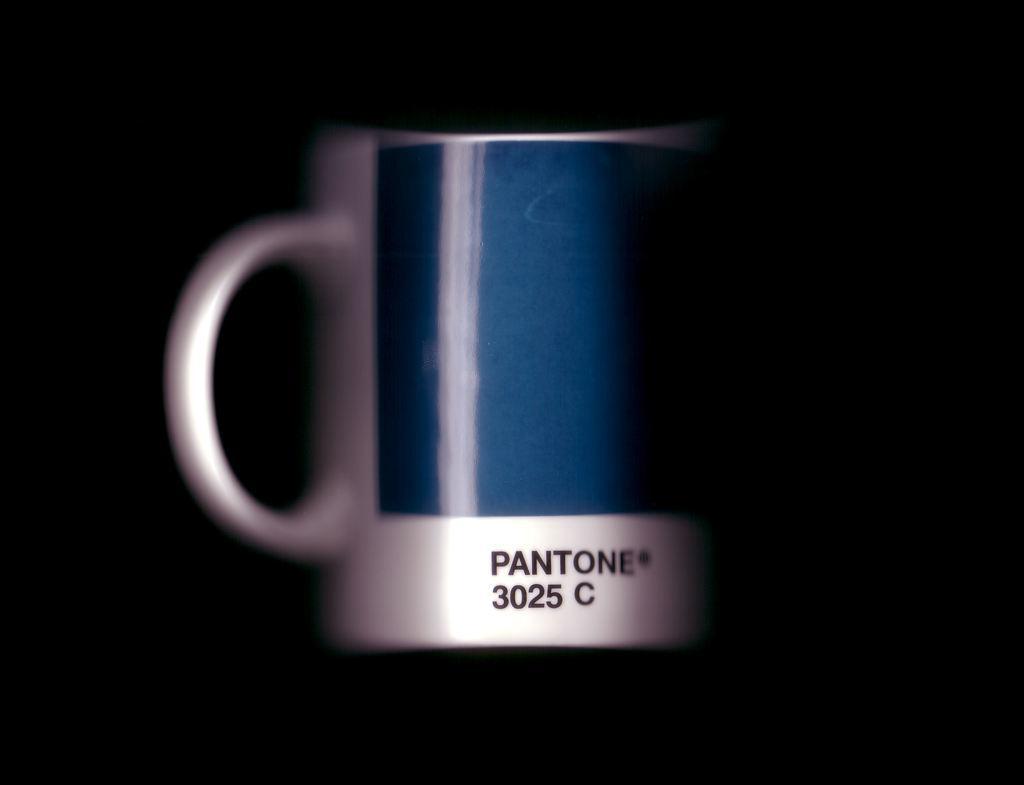Could you give a brief overview of what you see in this image? In this image there is a mug, on that mug there is some text, in the background it is dark. 